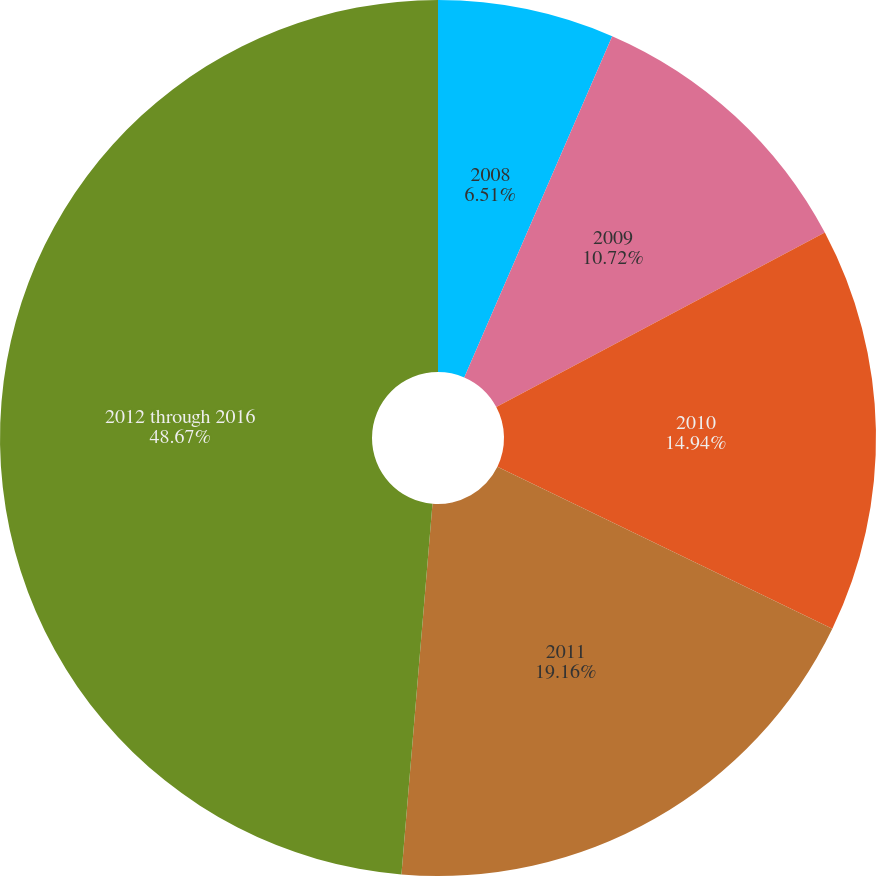Convert chart to OTSL. <chart><loc_0><loc_0><loc_500><loc_500><pie_chart><fcel>2008<fcel>2009<fcel>2010<fcel>2011<fcel>2012 through 2016<nl><fcel>6.51%<fcel>10.72%<fcel>14.94%<fcel>19.16%<fcel>48.67%<nl></chart> 